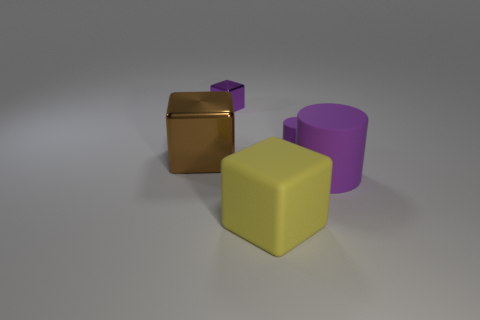Subtract all yellow cubes. How many cubes are left? 2 Add 3 big purple things. How many objects exist? 8 Subtract 1 cylinders. How many cylinders are left? 1 Subtract all cubes. How many objects are left? 2 Add 3 tiny yellow metal things. How many tiny yellow metal things exist? 3 Subtract 0 red balls. How many objects are left? 5 Subtract all brown blocks. Subtract all red cylinders. How many blocks are left? 2 Subtract all blue things. Subtract all large purple matte objects. How many objects are left? 4 Add 4 matte things. How many matte things are left? 7 